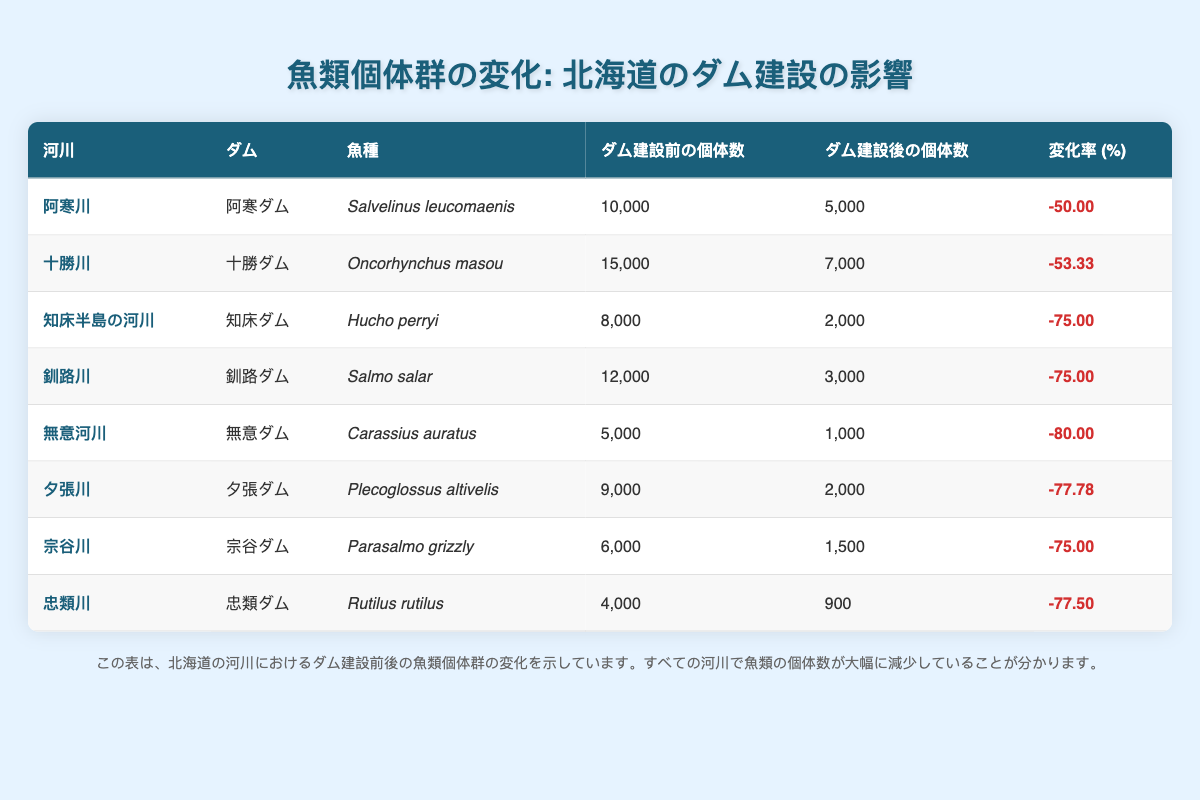What is the fish species found in the Kushiro River? According to the table, the species listed for the Kushiro River is Salmo salar.
Answer: Salmo salar Which river experienced the highest percentage decrease in fish population? By examining the change percentages, Muika River shows a decrease of -80%, which is the highest compared to other rivers in the table.
Answer: Muika River What was the fish population in the Akan River before the dam was built? The table indicates that the population before the dam in the Akan River was 10,000.
Answer: 10,000 How many rivers had a fish population decrease of 75% or more? The rivers with a decrease of 75% or more are Shiretoko Peninsula Rivers, Kushiro River, Muika River, Yūbari River, and Sōya River, totaling 5 rivers.
Answer: 5 True or False: The Tokachi River has a higher fish population after the dam compared to the Akan River. The Tokachi River has a population of 7,000 after the dam, while the Akan River has less, at 5,000 after the dam was built. Hence, the statement is false.
Answer: False What is the average fish population before damming for the rivers presented? The populations before damming sum up to 10,000 + 15,000 + 8,000 + 12,000 + 5,000 + 9,000 + 6,000 + 4,000 = 69,000. There are 8 rivers, so the average is 69,000 / 8 = 8,625.
Answer: 8,625 Which dam resulted in a fish population close to 1,000 after damming? The Muika Dam resulted in a population of 1,000 after damming, as indicated in the table.
Answer: Muika Dam Which river’s fish population decreased by the least percentage? The Akan River had a decrease of -50%, which is less compared to other rivers with higher decreases, such as -53.33, -75, -80, etc.
Answer: Akan River 